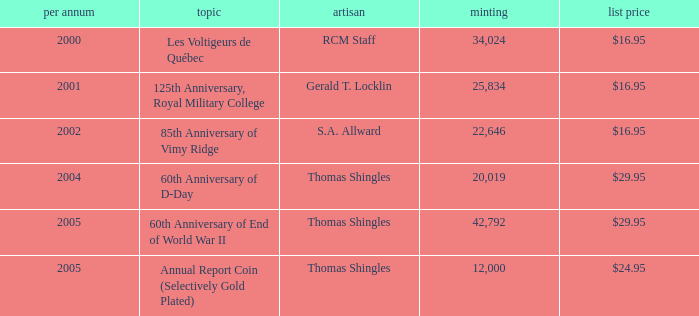Could you parse the entire table? {'header': ['per annum', 'topic', 'artisan', 'minting', 'list price'], 'rows': [['2000', 'Les Voltigeurs de Québec', 'RCM Staff', '34,024', '$16.95'], ['2001', '125th Anniversary, Royal Military College', 'Gerald T. Locklin', '25,834', '$16.95'], ['2002', '85th Anniversary of Vimy Ridge', 'S.A. Allward', '22,646', '$16.95'], ['2004', '60th Anniversary of D-Day', 'Thomas Shingles', '20,019', '$29.95'], ['2005', '60th Anniversary of End of World War II', 'Thomas Shingles', '42,792', '$29.95'], ['2005', 'Annual Report Coin (Selectively Gold Plated)', 'Thomas Shingles', '12,000', '$24.95']]} What was the total mintage for years after 2002 that had a 85th Anniversary of Vimy Ridge theme? 0.0. 